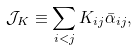Convert formula to latex. <formula><loc_0><loc_0><loc_500><loc_500>\mathcal { J } _ { K } \equiv \sum _ { i < j } K _ { i j } \bar { \alpha } _ { i j } ,</formula> 